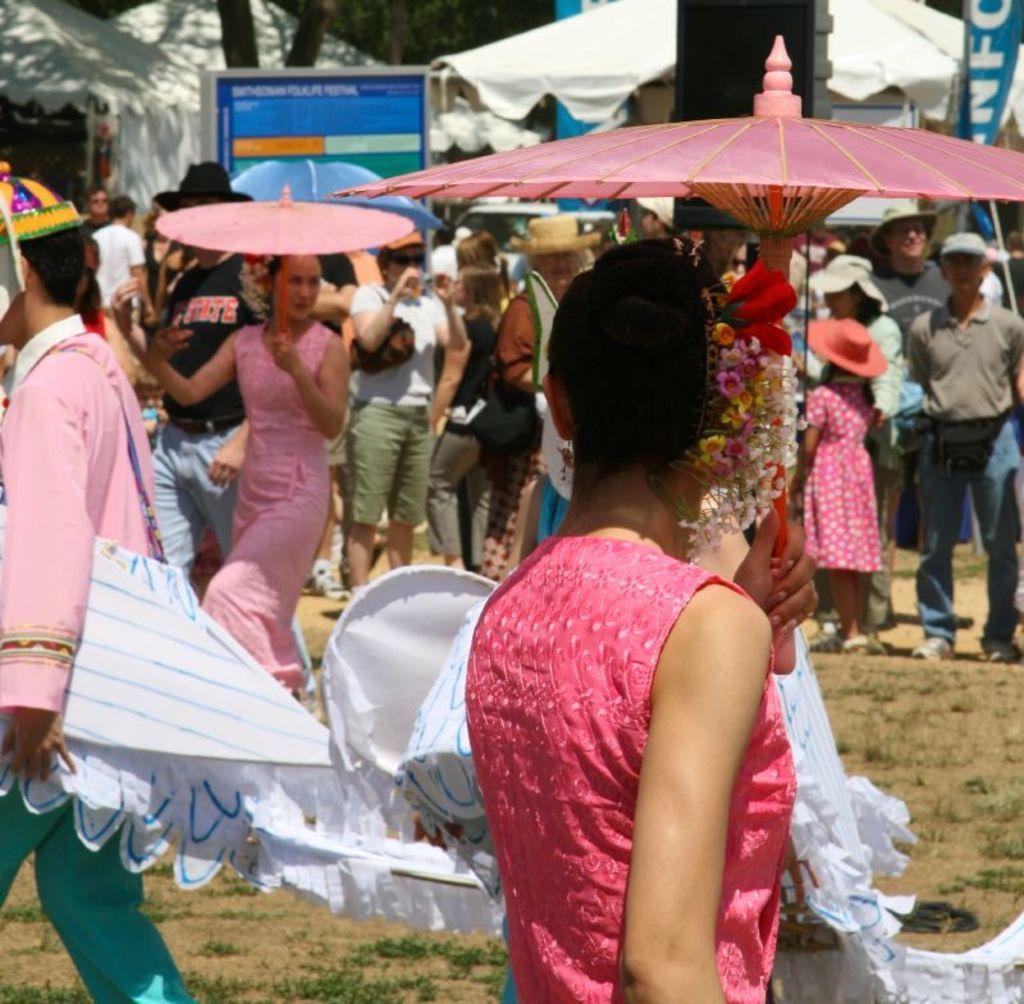How would you summarize this image in a sentence or two? In this image I can see number of people are standing and I can see few of them are holding umbrellas. I can also see most of them are wearing hats and in the front I can see one person is holding a white colour thing. In the background I can see few tents, few flags, a black colour speaker, a board and on it I can see something is written. 